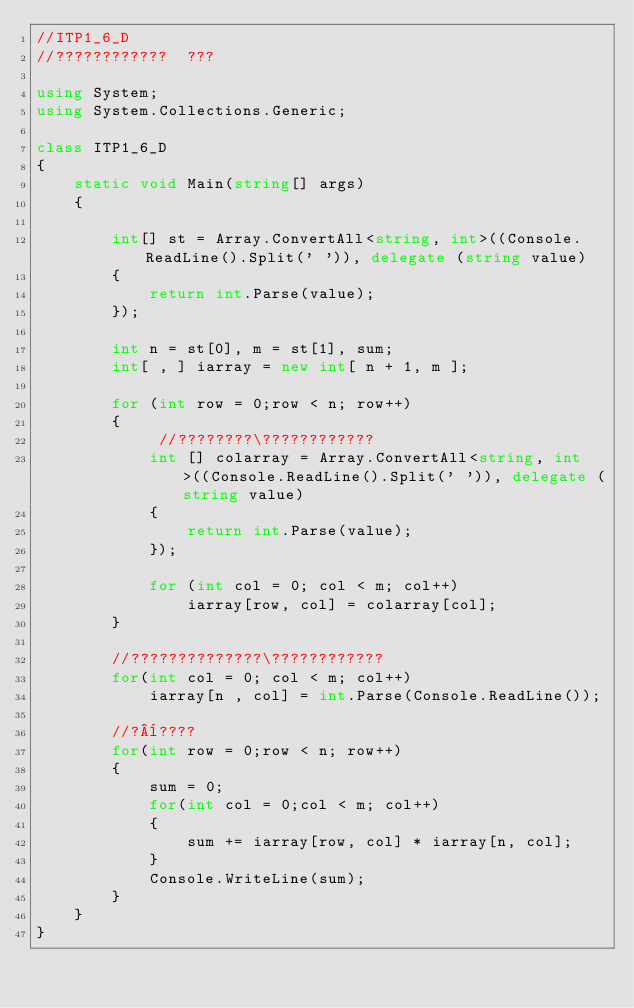<code> <loc_0><loc_0><loc_500><loc_500><_C#_>//ITP1_6_D
//????????????  ???

using System;
using System.Collections.Generic;

class ITP1_6_D
{
    static void Main(string[] args)
    {

        int[] st = Array.ConvertAll<string, int>((Console.ReadLine().Split(' ')), delegate (string value)
        {
            return int.Parse(value);
        });

        int n = st[0], m = st[1], sum;
        int[ , ] iarray = new int[ n + 1, m ];

        for (int row = 0;row < n; row++)
        {
             //????????\????????????
            int [] colarray = Array.ConvertAll<string, int>((Console.ReadLine().Split(' ')), delegate (string value)
            {
                return int.Parse(value);
            });

            for (int col = 0; col < m; col++)
                iarray[row, col] = colarray[col];
        }

        //??????????????\????????????
        for(int col = 0; col < m; col++)
            iarray[n , col] = int.Parse(Console.ReadLine());

        //?¨????
        for(int row = 0;row < n; row++)
        {
            sum = 0;
            for(int col = 0;col < m; col++)
            {
                sum += iarray[row, col] * iarray[n, col];
            }
            Console.WriteLine(sum);
        }
    }
}</code> 